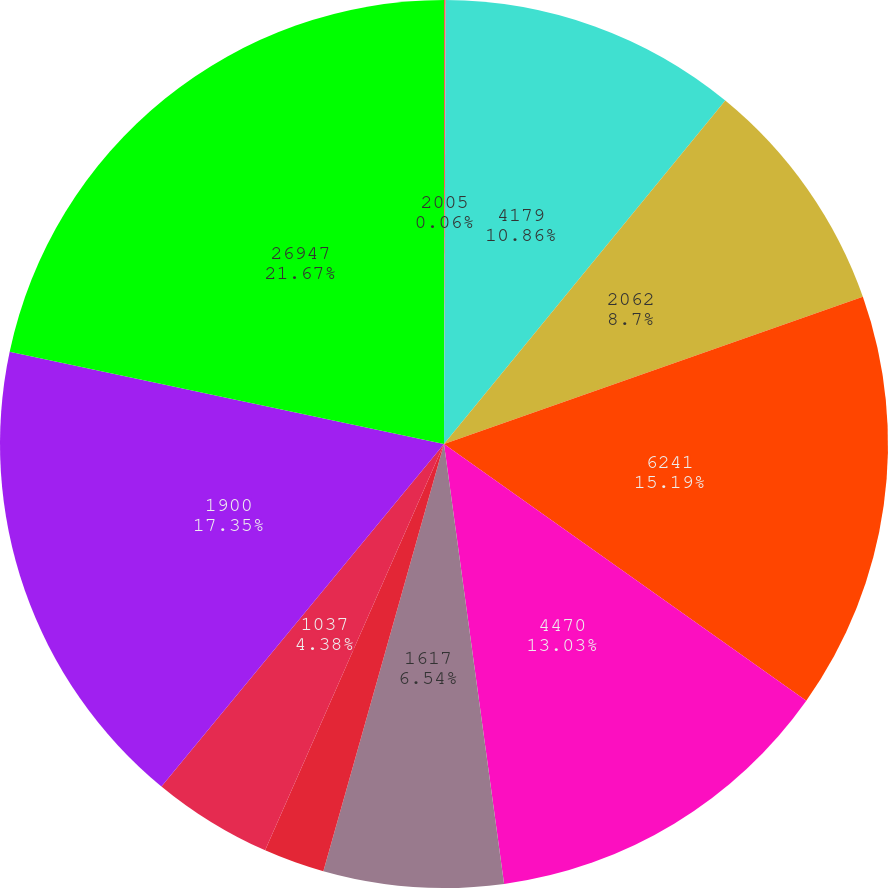Convert chart to OTSL. <chart><loc_0><loc_0><loc_500><loc_500><pie_chart><fcel>2005<fcel>4179<fcel>2062<fcel>6241<fcel>4470<fcel>1617<fcel>580<fcel>1037<fcel>1900<fcel>26947<nl><fcel>0.06%<fcel>10.86%<fcel>8.7%<fcel>15.19%<fcel>13.03%<fcel>6.54%<fcel>2.22%<fcel>4.38%<fcel>17.35%<fcel>21.67%<nl></chart> 